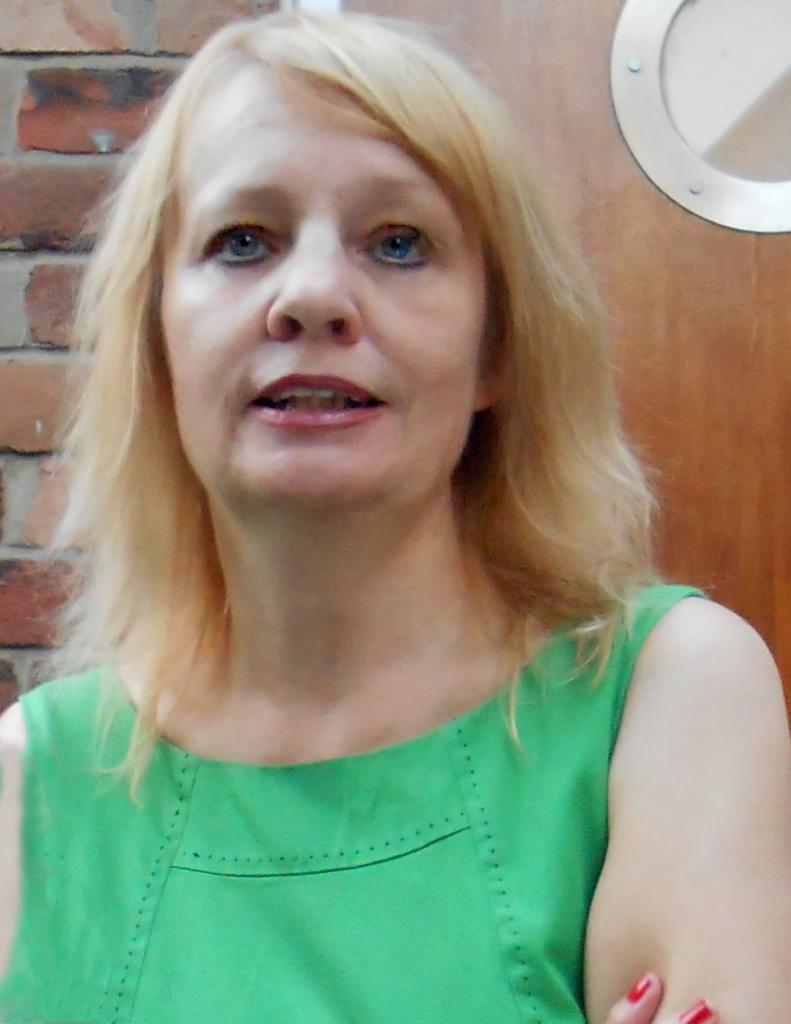What is the main subject in the foreground of the image? There is a person in the foreground of the image. What is the person wearing? The person is wearing a green dress. What can be seen in the background of the image? There is a wooden object and a brick wall in the background of the image. What does the caption say about the person in the image? There is no caption present in the image, so it is not possible to answer that question. 